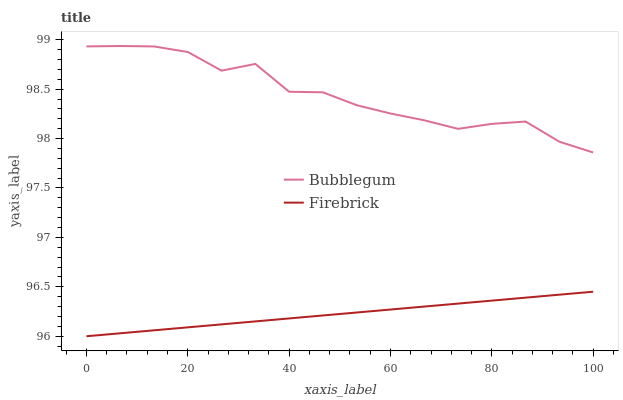Does Firebrick have the minimum area under the curve?
Answer yes or no. Yes. Does Bubblegum have the maximum area under the curve?
Answer yes or no. Yes. Does Bubblegum have the minimum area under the curve?
Answer yes or no. No. Is Firebrick the smoothest?
Answer yes or no. Yes. Is Bubblegum the roughest?
Answer yes or no. Yes. Is Bubblegum the smoothest?
Answer yes or no. No. Does Firebrick have the lowest value?
Answer yes or no. Yes. Does Bubblegum have the lowest value?
Answer yes or no. No. Does Bubblegum have the highest value?
Answer yes or no. Yes. Is Firebrick less than Bubblegum?
Answer yes or no. Yes. Is Bubblegum greater than Firebrick?
Answer yes or no. Yes. Does Firebrick intersect Bubblegum?
Answer yes or no. No. 